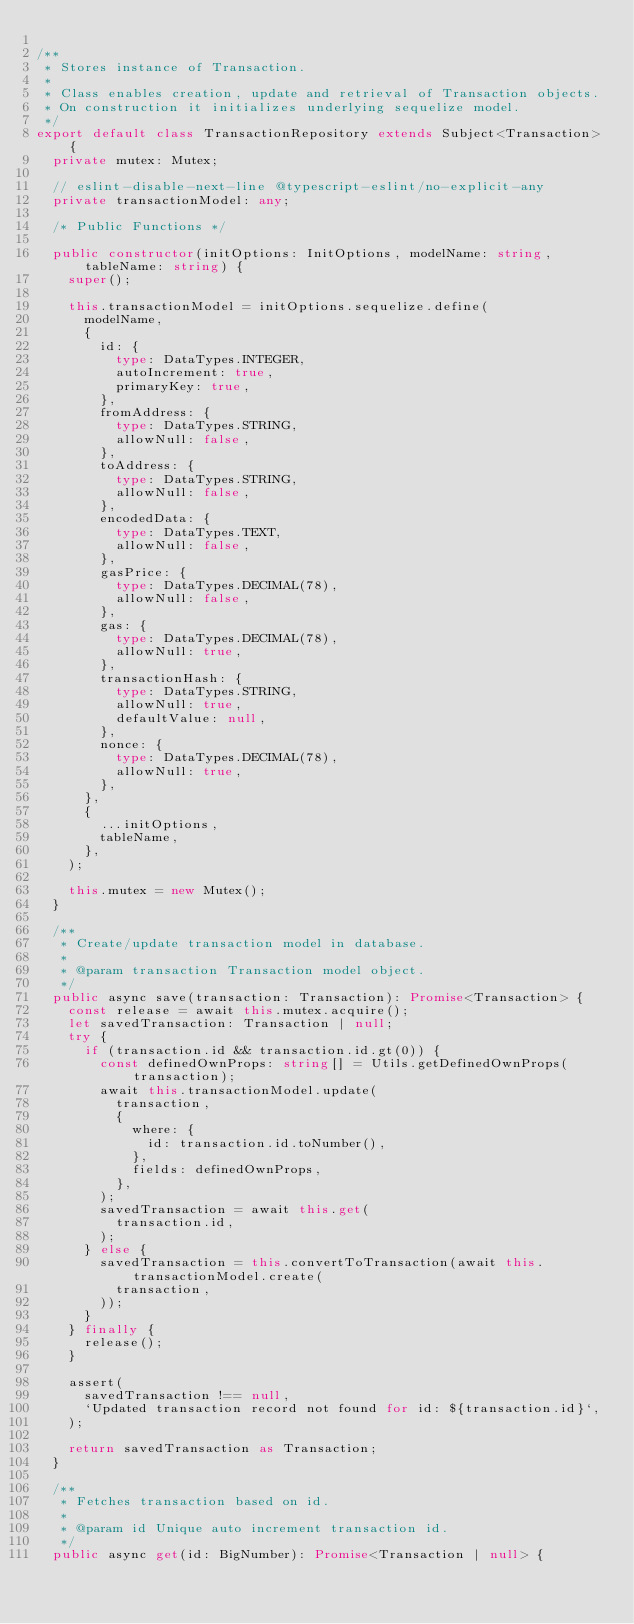Convert code to text. <code><loc_0><loc_0><loc_500><loc_500><_TypeScript_>
/**
 * Stores instance of Transaction.
 *
 * Class enables creation, update and retrieval of Transaction objects.
 * On construction it initializes underlying sequelize model.
 */
export default class TransactionRepository extends Subject<Transaction> {
  private mutex: Mutex;

  // eslint-disable-next-line @typescript-eslint/no-explicit-any
  private transactionModel: any;

  /* Public Functions */

  public constructor(initOptions: InitOptions, modelName: string, tableName: string) {
    super();

    this.transactionModel = initOptions.sequelize.define(
      modelName,
      {
        id: {
          type: DataTypes.INTEGER,
          autoIncrement: true,
          primaryKey: true,
        },
        fromAddress: {
          type: DataTypes.STRING,
          allowNull: false,
        },
        toAddress: {
          type: DataTypes.STRING,
          allowNull: false,
        },
        encodedData: {
          type: DataTypes.TEXT,
          allowNull: false,
        },
        gasPrice: {
          type: DataTypes.DECIMAL(78),
          allowNull: false,
        },
        gas: {
          type: DataTypes.DECIMAL(78),
          allowNull: true,
        },
        transactionHash: {
          type: DataTypes.STRING,
          allowNull: true,
          defaultValue: null,
        },
        nonce: {
          type: DataTypes.DECIMAL(78),
          allowNull: true,
        },
      },
      {
        ...initOptions,
        tableName,
      },
    );

    this.mutex = new Mutex();
  }

  /**
   * Create/update transaction model in database.
   *
   * @param transaction Transaction model object.
   */
  public async save(transaction: Transaction): Promise<Transaction> {
    const release = await this.mutex.acquire();
    let savedTransaction: Transaction | null;
    try {
      if (transaction.id && transaction.id.gt(0)) {
        const definedOwnProps: string[] = Utils.getDefinedOwnProps(transaction);
        await this.transactionModel.update(
          transaction,
          {
            where: {
              id: transaction.id.toNumber(),
            },
            fields: definedOwnProps,
          },
        );
        savedTransaction = await this.get(
          transaction.id,
        );
      } else {
        savedTransaction = this.convertToTransaction(await this.transactionModel.create(
          transaction,
        ));
      }
    } finally {
      release();
    }

    assert(
      savedTransaction !== null,
      `Updated transaction record not found for id: ${transaction.id}`,
    );

    return savedTransaction as Transaction;
  }

  /**
   * Fetches transaction based on id.
   *
   * @param id Unique auto increment transaction id.
   */
  public async get(id: BigNumber): Promise<Transaction | null> {</code> 